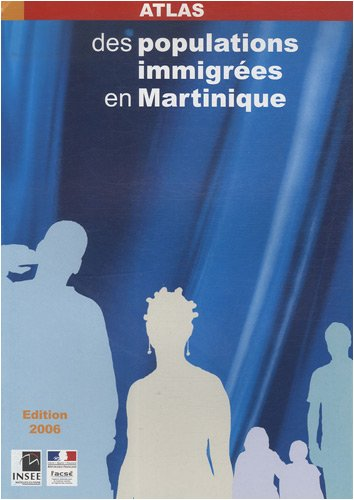Could you tell me about the type of data included in this atlas? The atlas likely includes various demographic statistics such as population density maps, age and gender distributions, and possibly socio-economic data related to immigrant groups in Martinique. 